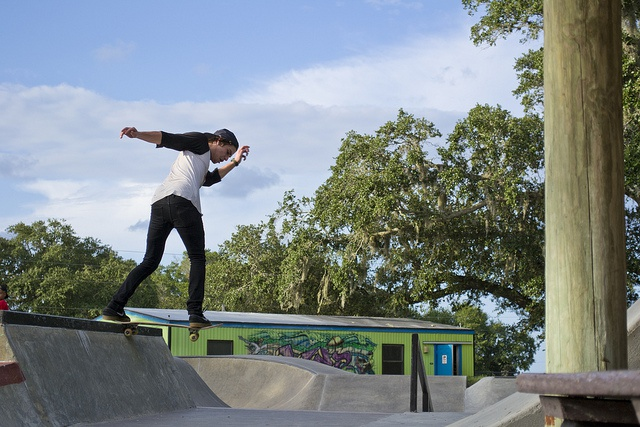Describe the objects in this image and their specific colors. I can see people in darkgray, black, lightgray, and gray tones and skateboard in darkgray, black, gray, and olive tones in this image. 